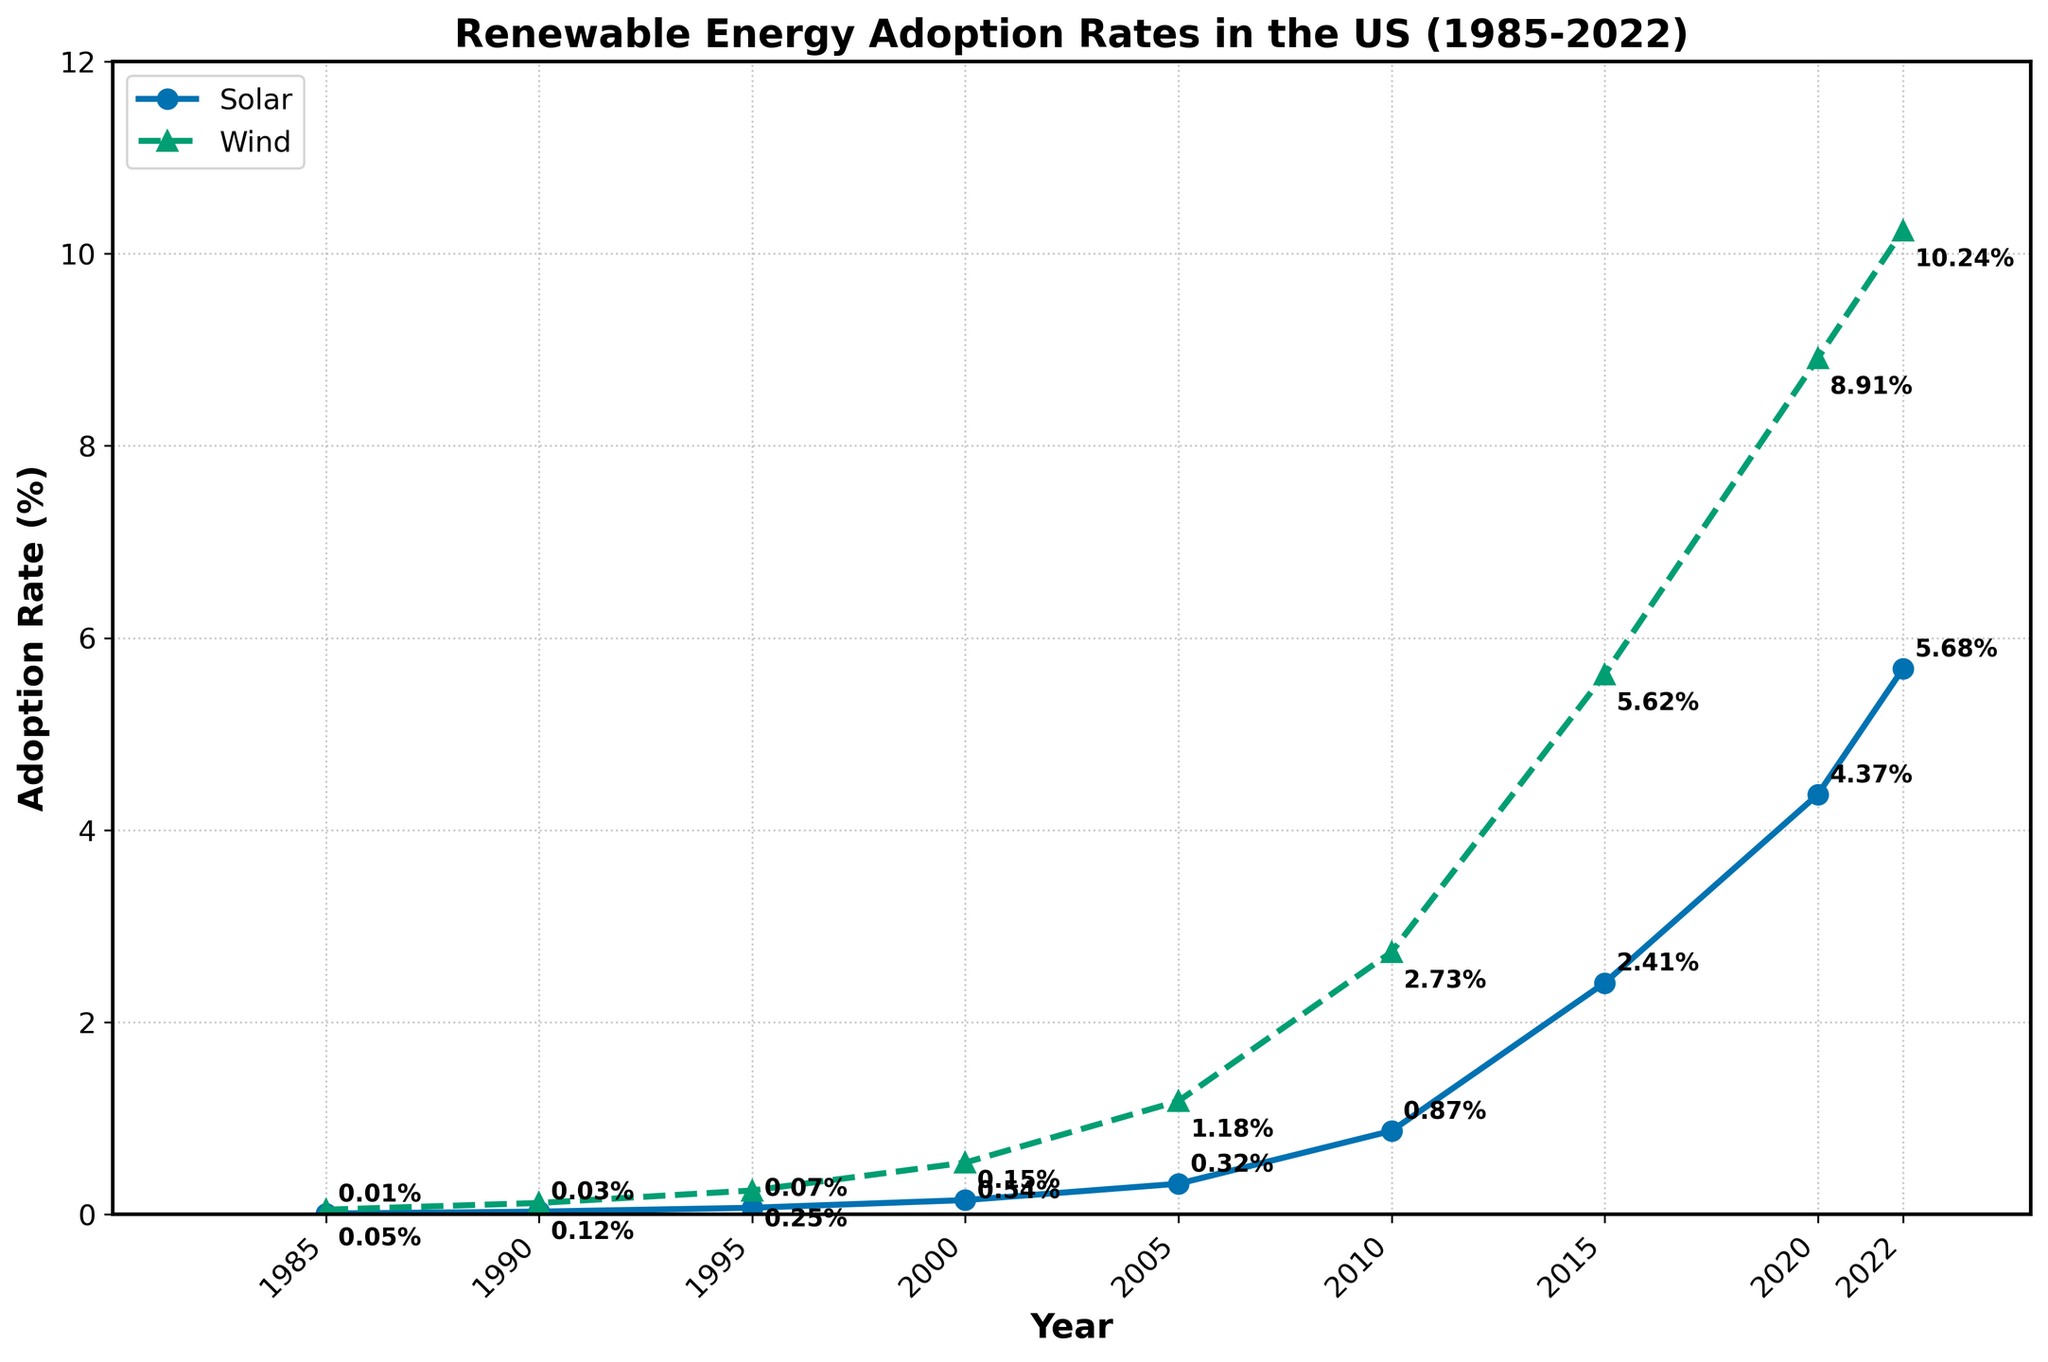Which year shows the highest adoption rate for wind energy? To find this, we need to look for the year where the wind adoption rate is at its maximum. As per the figure, 2022 shows the highest adoption rate for wind power at 10.24%.
Answer: 2022 In which year was the gap between wind and solar adoption rates the largest? We need to find the year where the difference between wind and solar adoption rates is the largest. Checking the data points, in 2010, the difference is 2.73% - 0.87% = 1.86%, which is the largest gap.
Answer: 2010 How much did the solar adoption rate increase between 1985 and 2022? Subtract the solar adoption rate in 1985 from the rate in 2022. 5.68% - 0.01% = 5.67%.
Answer: 5.67% What is the average adoption rate for solar energy between 1985 and 2022? Adding all the solar adoption rates from each year and dividing by the number of years (9): (0.01 + 0.03 + 0.07 + 0.15 + 0.32 + 0.87 + 2.41 + 4.37 + 5.68) / 9 ≈ 1.99%.
Answer: 1.99% How does the adoption rate growth of wind energy compare to solar energy from 2000 to 2020? We need to compare the increase in both energies from 2000 to 2020. Solar (from 0.15% to 4.37%): 4.37% - 0.15% = 4.22%. Wind (from 0.54% to 8.91%): 8.91% - 0.54% = 8.37%. Wind energy increased more.
Answer: Wind increased more Which energy source had a higher adoption rate in 1995? Comparing the 1995 data: solar adoption rate is 0.07% and wind adoption rate is 0.25%. Wind had the higher rate.
Answer: Wind What is the sum of the adoption rates for solar and wind in 2022? Adding the solar and wind adoption rates for 2022: 5.68% + 10.24% = 15.92%.
Answer: 15.92% Which adoption rate had a steeper increase from 1985 to 1990? From 1985 to 1990, solar increased from 0.01% to 0.03% (0.02% increase) and wind from 0.05% to 0.12% (0.07% increase). Wind had the steeper increase.
Answer: Wind Is the solar adoption rate in 2022 greater than the wind adoption rate in 2005? Comparing the two rates: solar in 2022 is 5.68% and wind in 2005 is 1.18%. Yes, solar in 2022 is greater.
Answer: Yes By how much did the wind adoption rate increase from 2005 to 2015? Subtract the 2005 wind adoption rate from the 2015 rate: 5.62% - 1.18% = 4.44%.
Answer: 4.44% 